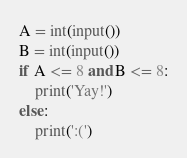Convert code to text. <code><loc_0><loc_0><loc_500><loc_500><_Python_>A = int(input())
B = int(input())
if A <= 8 and B <= 8:
    print('Yay!')
else:
    print(':(')</code> 